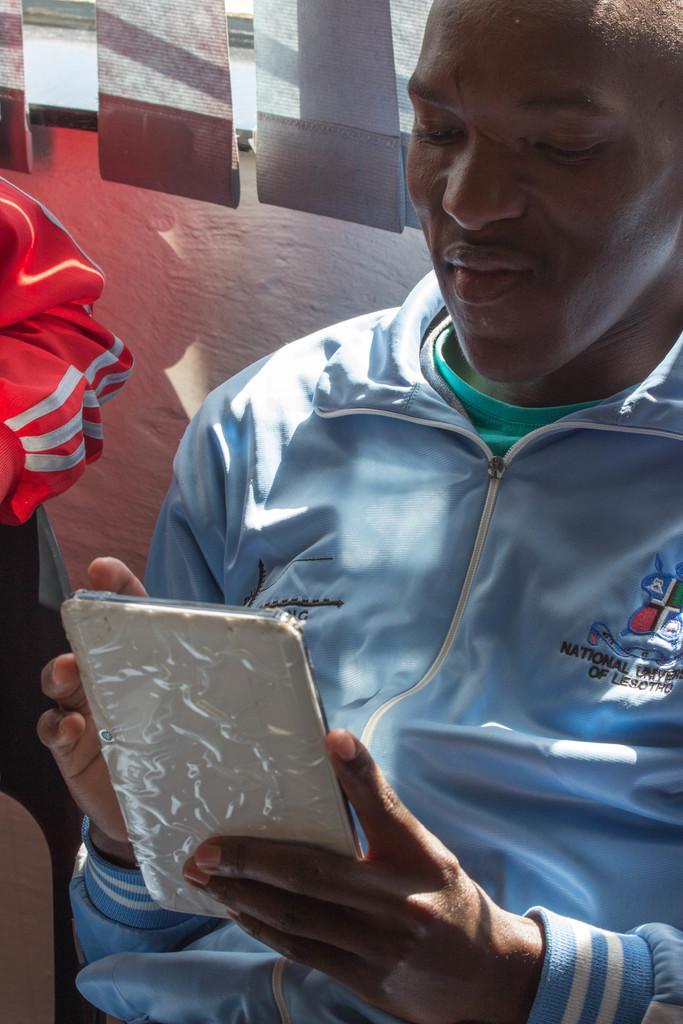How would you summarize this image in a sentence or two? In this picture there is a person in blue jacket holding a mobile. On the left we can see the hand of a person. At the top there is window and window blinds. 